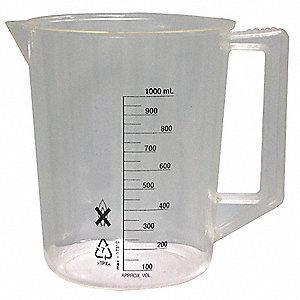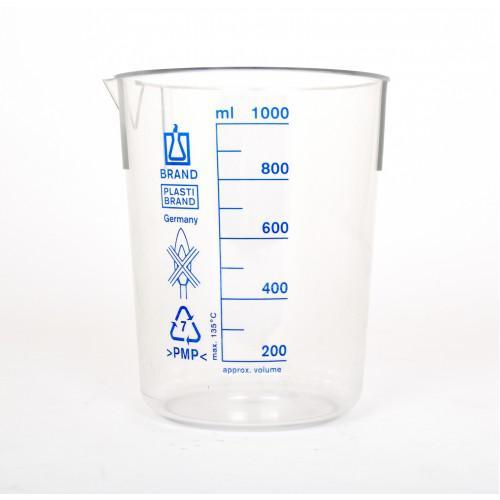The first image is the image on the left, the second image is the image on the right. For the images displayed, is the sentence "The measuring cup in one of the pictures has black writing and markings on it." factually correct? Answer yes or no. Yes. The first image is the image on the left, the second image is the image on the right. Evaluate the accuracy of this statement regarding the images: "The left and right image contains the same number of beakers with at least one with a handle.". Is it true? Answer yes or no. Yes. 